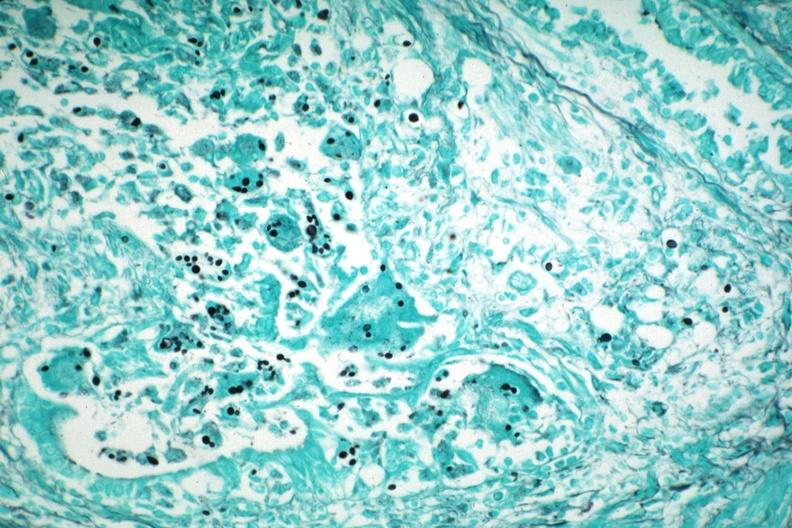s pneumocystis present?
Answer the question using a single word or phrase. Yes 